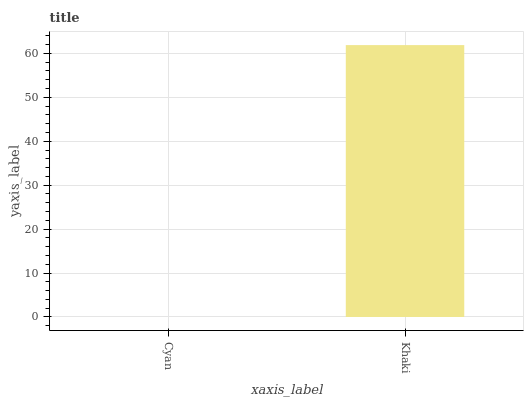Is Khaki the minimum?
Answer yes or no. No. Is Khaki greater than Cyan?
Answer yes or no. Yes. Is Cyan less than Khaki?
Answer yes or no. Yes. Is Cyan greater than Khaki?
Answer yes or no. No. Is Khaki less than Cyan?
Answer yes or no. No. Is Khaki the high median?
Answer yes or no. Yes. Is Cyan the low median?
Answer yes or no. Yes. Is Cyan the high median?
Answer yes or no. No. Is Khaki the low median?
Answer yes or no. No. 